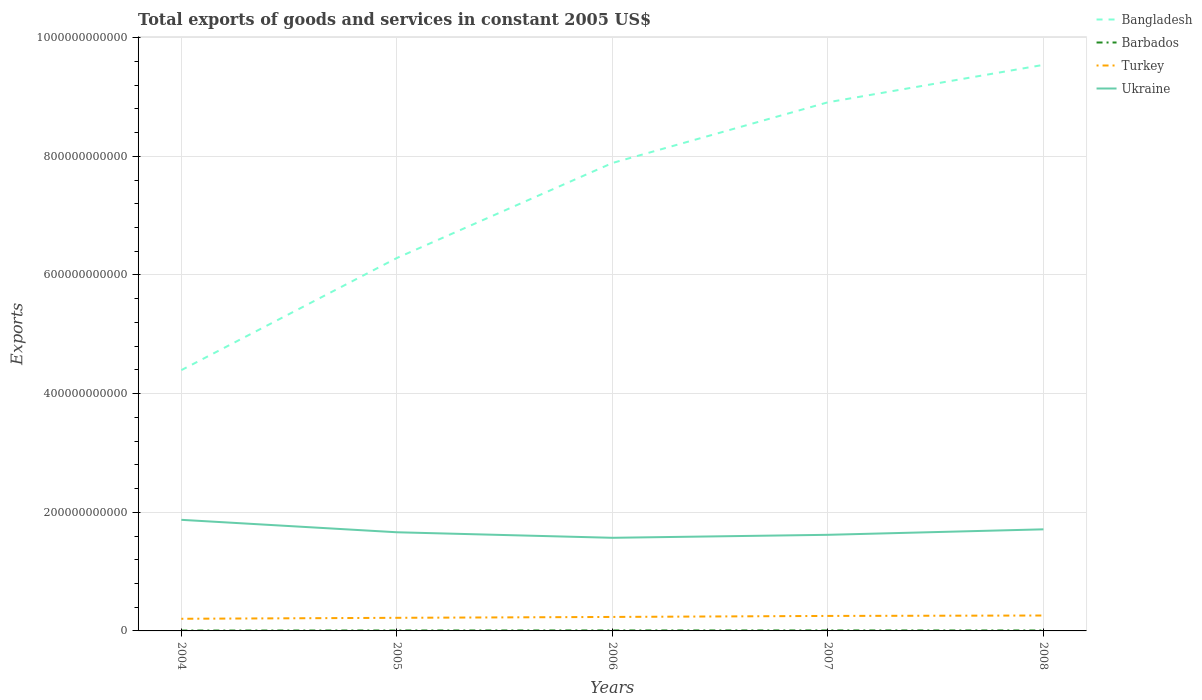How many different coloured lines are there?
Keep it short and to the point. 4. Across all years, what is the maximum total exports of goods and services in Barbados?
Your answer should be very brief. 6.44e+08. In which year was the total exports of goods and services in Barbados maximum?
Make the answer very short. 2004. What is the total total exports of goods and services in Barbados in the graph?
Give a very brief answer. 4.20e+07. What is the difference between the highest and the second highest total exports of goods and services in Turkey?
Your response must be concise. 5.49e+09. What is the difference between the highest and the lowest total exports of goods and services in Turkey?
Keep it short and to the point. 3. How many lines are there?
Your answer should be very brief. 4. What is the difference between two consecutive major ticks on the Y-axis?
Ensure brevity in your answer.  2.00e+11. Does the graph contain any zero values?
Keep it short and to the point. No. How many legend labels are there?
Your response must be concise. 4. What is the title of the graph?
Make the answer very short. Total exports of goods and services in constant 2005 US$. Does "Central African Republic" appear as one of the legend labels in the graph?
Your answer should be compact. No. What is the label or title of the Y-axis?
Give a very brief answer. Exports. What is the Exports in Bangladesh in 2004?
Give a very brief answer. 4.40e+11. What is the Exports in Barbados in 2004?
Provide a short and direct response. 6.44e+08. What is the Exports of Turkey in 2004?
Provide a short and direct response. 2.05e+1. What is the Exports of Ukraine in 2004?
Offer a very short reply. 1.87e+11. What is the Exports of Bangladesh in 2005?
Offer a terse response. 6.29e+11. What is the Exports in Barbados in 2005?
Ensure brevity in your answer.  7.50e+08. What is the Exports of Turkey in 2005?
Offer a very short reply. 2.21e+1. What is the Exports in Ukraine in 2005?
Give a very brief answer. 1.66e+11. What is the Exports of Bangladesh in 2006?
Your answer should be very brief. 7.89e+11. What is the Exports in Barbados in 2006?
Provide a short and direct response. 8.24e+08. What is the Exports of Turkey in 2006?
Provide a short and direct response. 2.36e+1. What is the Exports in Ukraine in 2006?
Make the answer very short. 1.57e+11. What is the Exports in Bangladesh in 2007?
Provide a short and direct response. 8.91e+11. What is the Exports of Barbados in 2007?
Your response must be concise. 8.18e+08. What is the Exports in Turkey in 2007?
Make the answer very short. 2.53e+1. What is the Exports in Ukraine in 2007?
Your answer should be compact. 1.62e+11. What is the Exports of Bangladesh in 2008?
Offer a very short reply. 9.54e+11. What is the Exports in Barbados in 2008?
Your response must be concise. 7.82e+08. What is the Exports in Turkey in 2008?
Keep it short and to the point. 2.60e+1. What is the Exports in Ukraine in 2008?
Make the answer very short. 1.71e+11. Across all years, what is the maximum Exports in Bangladesh?
Your answer should be compact. 9.54e+11. Across all years, what is the maximum Exports of Barbados?
Your answer should be very brief. 8.24e+08. Across all years, what is the maximum Exports of Turkey?
Your answer should be compact. 2.60e+1. Across all years, what is the maximum Exports in Ukraine?
Give a very brief answer. 1.87e+11. Across all years, what is the minimum Exports in Bangladesh?
Provide a succinct answer. 4.40e+11. Across all years, what is the minimum Exports in Barbados?
Ensure brevity in your answer.  6.44e+08. Across all years, what is the minimum Exports of Turkey?
Provide a short and direct response. 2.05e+1. Across all years, what is the minimum Exports in Ukraine?
Make the answer very short. 1.57e+11. What is the total Exports in Bangladesh in the graph?
Your answer should be compact. 3.70e+12. What is the total Exports in Barbados in the graph?
Provide a succinct answer. 3.82e+09. What is the total Exports of Turkey in the graph?
Keep it short and to the point. 1.17e+11. What is the total Exports of Ukraine in the graph?
Offer a terse response. 8.44e+11. What is the difference between the Exports in Bangladesh in 2004 and that in 2005?
Give a very brief answer. -1.89e+11. What is the difference between the Exports in Barbados in 2004 and that in 2005?
Provide a succinct answer. -1.06e+08. What is the difference between the Exports in Turkey in 2004 and that in 2005?
Provide a succinct answer. -1.62e+09. What is the difference between the Exports of Ukraine in 2004 and that in 2005?
Provide a succinct answer. 2.10e+1. What is the difference between the Exports in Bangladesh in 2004 and that in 2006?
Offer a very short reply. -3.49e+11. What is the difference between the Exports of Barbados in 2004 and that in 2006?
Keep it short and to the point. -1.80e+08. What is the difference between the Exports of Turkey in 2004 and that in 2006?
Your answer should be compact. -3.08e+09. What is the difference between the Exports in Ukraine in 2004 and that in 2006?
Keep it short and to the point. 3.03e+1. What is the difference between the Exports of Bangladesh in 2004 and that in 2007?
Offer a terse response. -4.52e+11. What is the difference between the Exports of Barbados in 2004 and that in 2007?
Your response must be concise. -1.74e+08. What is the difference between the Exports in Turkey in 2004 and that in 2007?
Offer a terse response. -4.80e+09. What is the difference between the Exports of Ukraine in 2004 and that in 2007?
Provide a short and direct response. 2.53e+1. What is the difference between the Exports of Bangladesh in 2004 and that in 2008?
Offer a terse response. -5.15e+11. What is the difference between the Exports of Barbados in 2004 and that in 2008?
Provide a succinct answer. -1.38e+08. What is the difference between the Exports in Turkey in 2004 and that in 2008?
Provide a succinct answer. -5.49e+09. What is the difference between the Exports in Ukraine in 2004 and that in 2008?
Provide a short and direct response. 1.60e+1. What is the difference between the Exports in Bangladesh in 2005 and that in 2006?
Make the answer very short. -1.60e+11. What is the difference between the Exports of Barbados in 2005 and that in 2006?
Provide a succinct answer. -7.40e+07. What is the difference between the Exports in Turkey in 2005 and that in 2006?
Ensure brevity in your answer.  -1.47e+09. What is the difference between the Exports of Ukraine in 2005 and that in 2006?
Give a very brief answer. 9.31e+09. What is the difference between the Exports in Bangladesh in 2005 and that in 2007?
Your answer should be compact. -2.63e+11. What is the difference between the Exports in Barbados in 2005 and that in 2007?
Your response must be concise. -6.80e+07. What is the difference between the Exports in Turkey in 2005 and that in 2007?
Offer a terse response. -3.18e+09. What is the difference between the Exports of Ukraine in 2005 and that in 2007?
Your answer should be very brief. 4.29e+09. What is the difference between the Exports of Bangladesh in 2005 and that in 2008?
Give a very brief answer. -3.26e+11. What is the difference between the Exports in Barbados in 2005 and that in 2008?
Your answer should be very brief. -3.20e+07. What is the difference between the Exports of Turkey in 2005 and that in 2008?
Give a very brief answer. -3.87e+09. What is the difference between the Exports in Ukraine in 2005 and that in 2008?
Ensure brevity in your answer.  -4.95e+09. What is the difference between the Exports in Bangladesh in 2006 and that in 2007?
Provide a succinct answer. -1.02e+11. What is the difference between the Exports of Barbados in 2006 and that in 2007?
Keep it short and to the point. 6.00e+06. What is the difference between the Exports in Turkey in 2006 and that in 2007?
Ensure brevity in your answer.  -1.71e+09. What is the difference between the Exports of Ukraine in 2006 and that in 2007?
Offer a very short reply. -5.02e+09. What is the difference between the Exports of Bangladesh in 2006 and that in 2008?
Offer a very short reply. -1.65e+11. What is the difference between the Exports of Barbados in 2006 and that in 2008?
Your answer should be very brief. 4.20e+07. What is the difference between the Exports of Turkey in 2006 and that in 2008?
Offer a very short reply. -2.40e+09. What is the difference between the Exports in Ukraine in 2006 and that in 2008?
Provide a short and direct response. -1.43e+1. What is the difference between the Exports of Bangladesh in 2007 and that in 2008?
Give a very brief answer. -6.31e+1. What is the difference between the Exports in Barbados in 2007 and that in 2008?
Offer a terse response. 3.60e+07. What is the difference between the Exports in Turkey in 2007 and that in 2008?
Keep it short and to the point. -6.93e+08. What is the difference between the Exports in Ukraine in 2007 and that in 2008?
Offer a terse response. -9.23e+09. What is the difference between the Exports of Bangladesh in 2004 and the Exports of Barbados in 2005?
Your response must be concise. 4.39e+11. What is the difference between the Exports in Bangladesh in 2004 and the Exports in Turkey in 2005?
Ensure brevity in your answer.  4.18e+11. What is the difference between the Exports of Bangladesh in 2004 and the Exports of Ukraine in 2005?
Offer a very short reply. 2.73e+11. What is the difference between the Exports in Barbados in 2004 and the Exports in Turkey in 2005?
Ensure brevity in your answer.  -2.15e+1. What is the difference between the Exports of Barbados in 2004 and the Exports of Ukraine in 2005?
Your answer should be very brief. -1.66e+11. What is the difference between the Exports of Turkey in 2004 and the Exports of Ukraine in 2005?
Offer a terse response. -1.46e+11. What is the difference between the Exports of Bangladesh in 2004 and the Exports of Barbados in 2006?
Your answer should be very brief. 4.39e+11. What is the difference between the Exports of Bangladesh in 2004 and the Exports of Turkey in 2006?
Give a very brief answer. 4.16e+11. What is the difference between the Exports of Bangladesh in 2004 and the Exports of Ukraine in 2006?
Offer a very short reply. 2.83e+11. What is the difference between the Exports of Barbados in 2004 and the Exports of Turkey in 2006?
Ensure brevity in your answer.  -2.29e+1. What is the difference between the Exports in Barbados in 2004 and the Exports in Ukraine in 2006?
Ensure brevity in your answer.  -1.56e+11. What is the difference between the Exports in Turkey in 2004 and the Exports in Ukraine in 2006?
Give a very brief answer. -1.37e+11. What is the difference between the Exports of Bangladesh in 2004 and the Exports of Barbados in 2007?
Your response must be concise. 4.39e+11. What is the difference between the Exports of Bangladesh in 2004 and the Exports of Turkey in 2007?
Offer a terse response. 4.14e+11. What is the difference between the Exports of Bangladesh in 2004 and the Exports of Ukraine in 2007?
Your answer should be very brief. 2.78e+11. What is the difference between the Exports of Barbados in 2004 and the Exports of Turkey in 2007?
Your answer should be very brief. -2.46e+1. What is the difference between the Exports of Barbados in 2004 and the Exports of Ukraine in 2007?
Offer a very short reply. -1.61e+11. What is the difference between the Exports of Turkey in 2004 and the Exports of Ukraine in 2007?
Give a very brief answer. -1.42e+11. What is the difference between the Exports in Bangladesh in 2004 and the Exports in Barbados in 2008?
Ensure brevity in your answer.  4.39e+11. What is the difference between the Exports of Bangladesh in 2004 and the Exports of Turkey in 2008?
Offer a very short reply. 4.14e+11. What is the difference between the Exports of Bangladesh in 2004 and the Exports of Ukraine in 2008?
Make the answer very short. 2.68e+11. What is the difference between the Exports in Barbados in 2004 and the Exports in Turkey in 2008?
Ensure brevity in your answer.  -2.53e+1. What is the difference between the Exports of Barbados in 2004 and the Exports of Ukraine in 2008?
Make the answer very short. -1.71e+11. What is the difference between the Exports of Turkey in 2004 and the Exports of Ukraine in 2008?
Give a very brief answer. -1.51e+11. What is the difference between the Exports in Bangladesh in 2005 and the Exports in Barbados in 2006?
Your response must be concise. 6.28e+11. What is the difference between the Exports of Bangladesh in 2005 and the Exports of Turkey in 2006?
Your response must be concise. 6.05e+11. What is the difference between the Exports of Bangladesh in 2005 and the Exports of Ukraine in 2006?
Your answer should be compact. 4.72e+11. What is the difference between the Exports in Barbados in 2005 and the Exports in Turkey in 2006?
Provide a succinct answer. -2.28e+1. What is the difference between the Exports in Barbados in 2005 and the Exports in Ukraine in 2006?
Your answer should be very brief. -1.56e+11. What is the difference between the Exports in Turkey in 2005 and the Exports in Ukraine in 2006?
Give a very brief answer. -1.35e+11. What is the difference between the Exports in Bangladesh in 2005 and the Exports in Barbados in 2007?
Provide a succinct answer. 6.28e+11. What is the difference between the Exports in Bangladesh in 2005 and the Exports in Turkey in 2007?
Make the answer very short. 6.03e+11. What is the difference between the Exports of Bangladesh in 2005 and the Exports of Ukraine in 2007?
Offer a terse response. 4.67e+11. What is the difference between the Exports of Barbados in 2005 and the Exports of Turkey in 2007?
Provide a short and direct response. -2.45e+1. What is the difference between the Exports of Barbados in 2005 and the Exports of Ukraine in 2007?
Give a very brief answer. -1.61e+11. What is the difference between the Exports in Turkey in 2005 and the Exports in Ukraine in 2007?
Your answer should be compact. -1.40e+11. What is the difference between the Exports of Bangladesh in 2005 and the Exports of Barbados in 2008?
Your answer should be very brief. 6.28e+11. What is the difference between the Exports in Bangladesh in 2005 and the Exports in Turkey in 2008?
Offer a very short reply. 6.03e+11. What is the difference between the Exports of Bangladesh in 2005 and the Exports of Ukraine in 2008?
Make the answer very short. 4.57e+11. What is the difference between the Exports in Barbados in 2005 and the Exports in Turkey in 2008?
Your response must be concise. -2.52e+1. What is the difference between the Exports in Barbados in 2005 and the Exports in Ukraine in 2008?
Offer a very short reply. -1.71e+11. What is the difference between the Exports of Turkey in 2005 and the Exports of Ukraine in 2008?
Provide a short and direct response. -1.49e+11. What is the difference between the Exports in Bangladesh in 2006 and the Exports in Barbados in 2007?
Offer a very short reply. 7.88e+11. What is the difference between the Exports in Bangladesh in 2006 and the Exports in Turkey in 2007?
Your response must be concise. 7.64e+11. What is the difference between the Exports of Bangladesh in 2006 and the Exports of Ukraine in 2007?
Give a very brief answer. 6.27e+11. What is the difference between the Exports in Barbados in 2006 and the Exports in Turkey in 2007?
Keep it short and to the point. -2.45e+1. What is the difference between the Exports of Barbados in 2006 and the Exports of Ukraine in 2007?
Your answer should be compact. -1.61e+11. What is the difference between the Exports of Turkey in 2006 and the Exports of Ukraine in 2007?
Provide a short and direct response. -1.38e+11. What is the difference between the Exports in Bangladesh in 2006 and the Exports in Barbados in 2008?
Your answer should be very brief. 7.88e+11. What is the difference between the Exports of Bangladesh in 2006 and the Exports of Turkey in 2008?
Provide a succinct answer. 7.63e+11. What is the difference between the Exports of Bangladesh in 2006 and the Exports of Ukraine in 2008?
Your answer should be very brief. 6.18e+11. What is the difference between the Exports of Barbados in 2006 and the Exports of Turkey in 2008?
Make the answer very short. -2.51e+1. What is the difference between the Exports of Barbados in 2006 and the Exports of Ukraine in 2008?
Make the answer very short. -1.70e+11. What is the difference between the Exports in Turkey in 2006 and the Exports in Ukraine in 2008?
Keep it short and to the point. -1.48e+11. What is the difference between the Exports in Bangladesh in 2007 and the Exports in Barbados in 2008?
Make the answer very short. 8.90e+11. What is the difference between the Exports of Bangladesh in 2007 and the Exports of Turkey in 2008?
Provide a short and direct response. 8.65e+11. What is the difference between the Exports in Bangladesh in 2007 and the Exports in Ukraine in 2008?
Make the answer very short. 7.20e+11. What is the difference between the Exports in Barbados in 2007 and the Exports in Turkey in 2008?
Ensure brevity in your answer.  -2.52e+1. What is the difference between the Exports of Barbados in 2007 and the Exports of Ukraine in 2008?
Keep it short and to the point. -1.70e+11. What is the difference between the Exports in Turkey in 2007 and the Exports in Ukraine in 2008?
Make the answer very short. -1.46e+11. What is the average Exports of Bangladesh per year?
Make the answer very short. 7.40e+11. What is the average Exports of Barbados per year?
Your answer should be compact. 7.64e+08. What is the average Exports of Turkey per year?
Ensure brevity in your answer.  2.35e+1. What is the average Exports of Ukraine per year?
Your answer should be very brief. 1.69e+11. In the year 2004, what is the difference between the Exports of Bangladesh and Exports of Barbados?
Provide a short and direct response. 4.39e+11. In the year 2004, what is the difference between the Exports in Bangladesh and Exports in Turkey?
Make the answer very short. 4.19e+11. In the year 2004, what is the difference between the Exports of Bangladesh and Exports of Ukraine?
Give a very brief answer. 2.52e+11. In the year 2004, what is the difference between the Exports of Barbados and Exports of Turkey?
Provide a succinct answer. -1.98e+1. In the year 2004, what is the difference between the Exports of Barbados and Exports of Ukraine?
Make the answer very short. -1.87e+11. In the year 2004, what is the difference between the Exports of Turkey and Exports of Ukraine?
Offer a very short reply. -1.67e+11. In the year 2005, what is the difference between the Exports of Bangladesh and Exports of Barbados?
Keep it short and to the point. 6.28e+11. In the year 2005, what is the difference between the Exports in Bangladesh and Exports in Turkey?
Your answer should be very brief. 6.07e+11. In the year 2005, what is the difference between the Exports of Bangladesh and Exports of Ukraine?
Your answer should be very brief. 4.62e+11. In the year 2005, what is the difference between the Exports in Barbados and Exports in Turkey?
Provide a succinct answer. -2.13e+1. In the year 2005, what is the difference between the Exports of Barbados and Exports of Ukraine?
Your answer should be very brief. -1.66e+11. In the year 2005, what is the difference between the Exports in Turkey and Exports in Ukraine?
Give a very brief answer. -1.44e+11. In the year 2006, what is the difference between the Exports in Bangladesh and Exports in Barbados?
Provide a succinct answer. 7.88e+11. In the year 2006, what is the difference between the Exports in Bangladesh and Exports in Turkey?
Your answer should be very brief. 7.65e+11. In the year 2006, what is the difference between the Exports of Bangladesh and Exports of Ukraine?
Provide a short and direct response. 6.32e+11. In the year 2006, what is the difference between the Exports of Barbados and Exports of Turkey?
Ensure brevity in your answer.  -2.27e+1. In the year 2006, what is the difference between the Exports of Barbados and Exports of Ukraine?
Ensure brevity in your answer.  -1.56e+11. In the year 2006, what is the difference between the Exports of Turkey and Exports of Ukraine?
Offer a terse response. -1.33e+11. In the year 2007, what is the difference between the Exports in Bangladesh and Exports in Barbados?
Offer a very short reply. 8.90e+11. In the year 2007, what is the difference between the Exports of Bangladesh and Exports of Turkey?
Keep it short and to the point. 8.66e+11. In the year 2007, what is the difference between the Exports in Bangladesh and Exports in Ukraine?
Offer a terse response. 7.29e+11. In the year 2007, what is the difference between the Exports in Barbados and Exports in Turkey?
Keep it short and to the point. -2.45e+1. In the year 2007, what is the difference between the Exports in Barbados and Exports in Ukraine?
Ensure brevity in your answer.  -1.61e+11. In the year 2007, what is the difference between the Exports of Turkey and Exports of Ukraine?
Ensure brevity in your answer.  -1.37e+11. In the year 2008, what is the difference between the Exports in Bangladesh and Exports in Barbados?
Make the answer very short. 9.53e+11. In the year 2008, what is the difference between the Exports of Bangladesh and Exports of Turkey?
Ensure brevity in your answer.  9.28e+11. In the year 2008, what is the difference between the Exports in Bangladesh and Exports in Ukraine?
Provide a short and direct response. 7.83e+11. In the year 2008, what is the difference between the Exports of Barbados and Exports of Turkey?
Provide a short and direct response. -2.52e+1. In the year 2008, what is the difference between the Exports of Barbados and Exports of Ukraine?
Make the answer very short. -1.70e+11. In the year 2008, what is the difference between the Exports of Turkey and Exports of Ukraine?
Provide a short and direct response. -1.45e+11. What is the ratio of the Exports in Bangladesh in 2004 to that in 2005?
Offer a very short reply. 0.7. What is the ratio of the Exports of Barbados in 2004 to that in 2005?
Provide a short and direct response. 0.86. What is the ratio of the Exports in Turkey in 2004 to that in 2005?
Your answer should be compact. 0.93. What is the ratio of the Exports in Ukraine in 2004 to that in 2005?
Your response must be concise. 1.13. What is the ratio of the Exports of Bangladesh in 2004 to that in 2006?
Offer a terse response. 0.56. What is the ratio of the Exports in Barbados in 2004 to that in 2006?
Your answer should be compact. 0.78. What is the ratio of the Exports in Turkey in 2004 to that in 2006?
Make the answer very short. 0.87. What is the ratio of the Exports of Ukraine in 2004 to that in 2006?
Your answer should be compact. 1.19. What is the ratio of the Exports of Bangladesh in 2004 to that in 2007?
Provide a short and direct response. 0.49. What is the ratio of the Exports of Barbados in 2004 to that in 2007?
Keep it short and to the point. 0.79. What is the ratio of the Exports of Turkey in 2004 to that in 2007?
Give a very brief answer. 0.81. What is the ratio of the Exports in Ukraine in 2004 to that in 2007?
Ensure brevity in your answer.  1.16. What is the ratio of the Exports in Bangladesh in 2004 to that in 2008?
Give a very brief answer. 0.46. What is the ratio of the Exports of Barbados in 2004 to that in 2008?
Ensure brevity in your answer.  0.82. What is the ratio of the Exports of Turkey in 2004 to that in 2008?
Offer a terse response. 0.79. What is the ratio of the Exports in Ukraine in 2004 to that in 2008?
Give a very brief answer. 1.09. What is the ratio of the Exports in Bangladesh in 2005 to that in 2006?
Your answer should be compact. 0.8. What is the ratio of the Exports in Barbados in 2005 to that in 2006?
Give a very brief answer. 0.91. What is the ratio of the Exports of Turkey in 2005 to that in 2006?
Provide a succinct answer. 0.94. What is the ratio of the Exports of Ukraine in 2005 to that in 2006?
Your answer should be compact. 1.06. What is the ratio of the Exports of Bangladesh in 2005 to that in 2007?
Your response must be concise. 0.71. What is the ratio of the Exports in Barbados in 2005 to that in 2007?
Offer a terse response. 0.92. What is the ratio of the Exports in Turkey in 2005 to that in 2007?
Provide a short and direct response. 0.87. What is the ratio of the Exports in Ukraine in 2005 to that in 2007?
Your response must be concise. 1.03. What is the ratio of the Exports of Bangladesh in 2005 to that in 2008?
Your answer should be compact. 0.66. What is the ratio of the Exports of Barbados in 2005 to that in 2008?
Your answer should be compact. 0.96. What is the ratio of the Exports of Turkey in 2005 to that in 2008?
Provide a short and direct response. 0.85. What is the ratio of the Exports of Ukraine in 2005 to that in 2008?
Keep it short and to the point. 0.97. What is the ratio of the Exports of Bangladesh in 2006 to that in 2007?
Make the answer very short. 0.89. What is the ratio of the Exports of Barbados in 2006 to that in 2007?
Provide a succinct answer. 1.01. What is the ratio of the Exports in Turkey in 2006 to that in 2007?
Offer a terse response. 0.93. What is the ratio of the Exports of Ukraine in 2006 to that in 2007?
Offer a terse response. 0.97. What is the ratio of the Exports in Bangladesh in 2006 to that in 2008?
Keep it short and to the point. 0.83. What is the ratio of the Exports of Barbados in 2006 to that in 2008?
Ensure brevity in your answer.  1.05. What is the ratio of the Exports in Turkey in 2006 to that in 2008?
Keep it short and to the point. 0.91. What is the ratio of the Exports in Bangladesh in 2007 to that in 2008?
Offer a terse response. 0.93. What is the ratio of the Exports of Barbados in 2007 to that in 2008?
Your response must be concise. 1.05. What is the ratio of the Exports of Turkey in 2007 to that in 2008?
Give a very brief answer. 0.97. What is the ratio of the Exports in Ukraine in 2007 to that in 2008?
Make the answer very short. 0.95. What is the difference between the highest and the second highest Exports in Bangladesh?
Give a very brief answer. 6.31e+1. What is the difference between the highest and the second highest Exports of Turkey?
Give a very brief answer. 6.93e+08. What is the difference between the highest and the second highest Exports of Ukraine?
Your answer should be very brief. 1.60e+1. What is the difference between the highest and the lowest Exports of Bangladesh?
Provide a short and direct response. 5.15e+11. What is the difference between the highest and the lowest Exports of Barbados?
Offer a terse response. 1.80e+08. What is the difference between the highest and the lowest Exports of Turkey?
Provide a succinct answer. 5.49e+09. What is the difference between the highest and the lowest Exports of Ukraine?
Provide a succinct answer. 3.03e+1. 